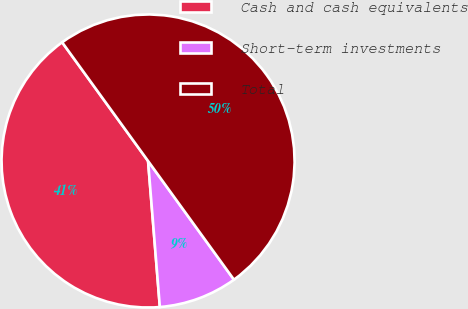<chart> <loc_0><loc_0><loc_500><loc_500><pie_chart><fcel>Cash and cash equivalents<fcel>Short-term investments<fcel>Total<nl><fcel>41.31%<fcel>8.69%<fcel>50.0%<nl></chart> 